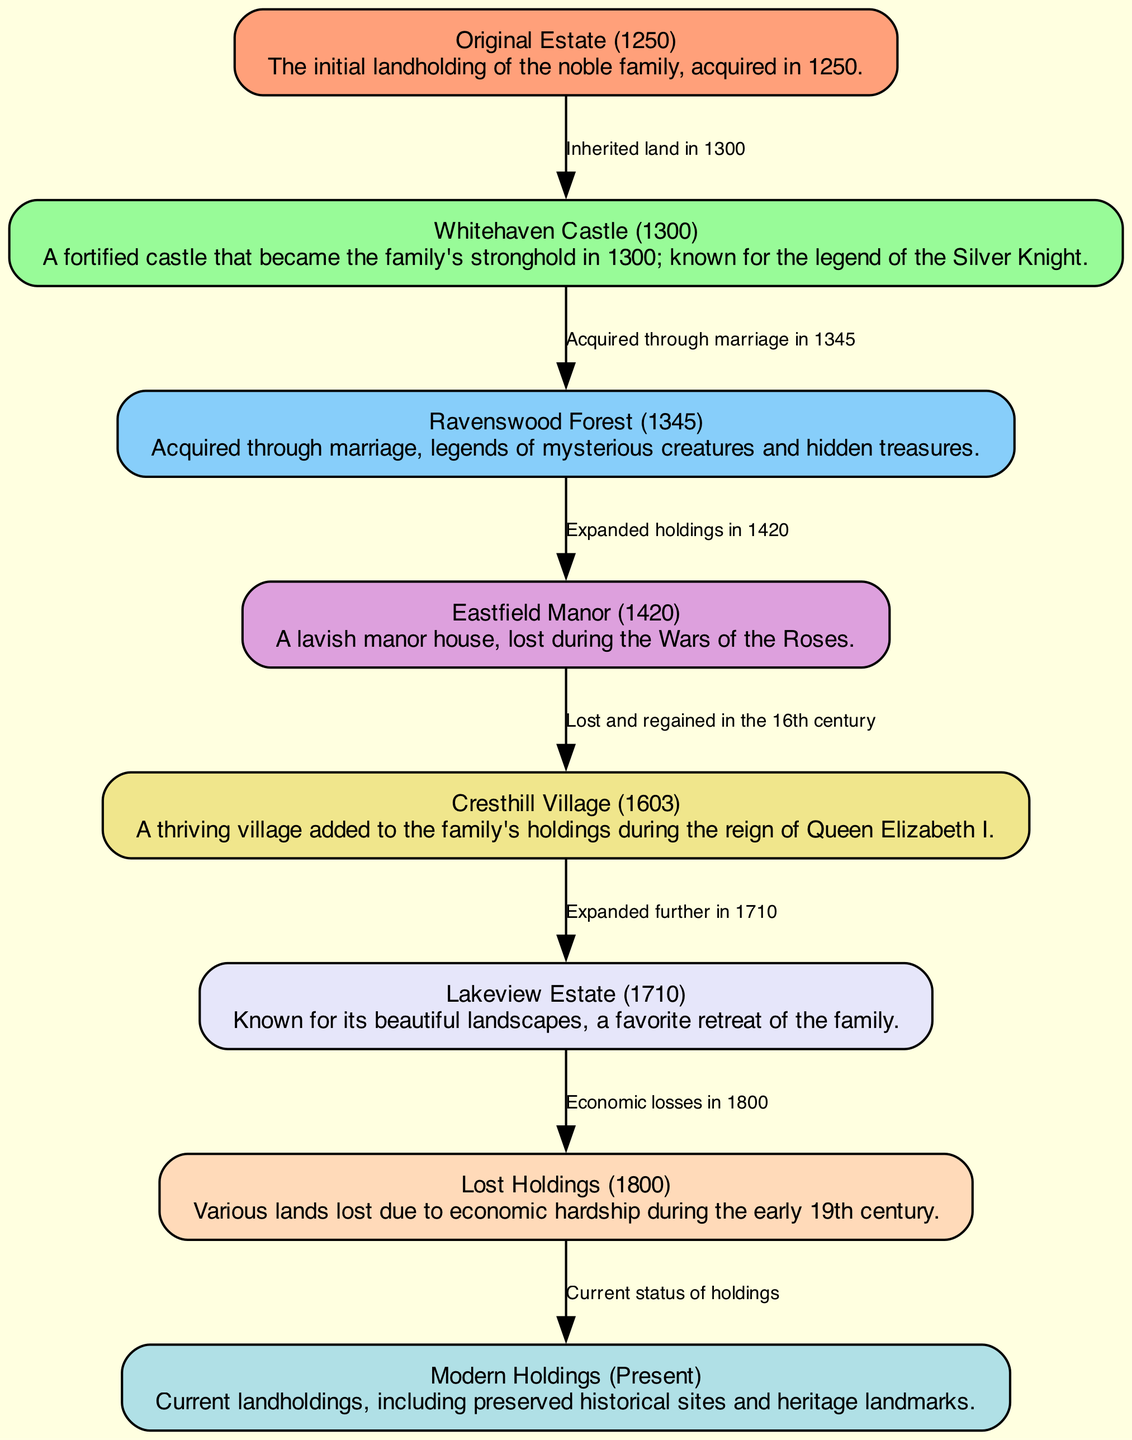What year was the Original Estate acquired? The diagram states that the Original Estate was acquired in the year 1250, as indicated in the node description.
Answer: 1250 How many significant landholdings are mentioned in the diagram? The diagram lists 8 significant landholdings, each represented as a node in the visualization.
Answer: 8 What landmark is associated with the legend of the Silver Knight? The node for Whitehaven Castle specifically mentions the legend of the Silver Knight, which is its notable story.
Answer: Whitehaven Castle Which holdings were lost during the Wars of the Roses? The node for Eastfield Manor describes it as being lost during the Wars of the Roses, indicating the specific event related to the family’s holdings.
Answer: Eastfield Manor What is the current status of landholdings according to the diagram? The last node identifies the current holdings as "Modern Holdings," which reflects the present status of the noble family's land.
Answer: Modern Holdings What connection exists between Ravenswood Forest and Eastfield Manor? The edge connecting Ravenswood Forest to Eastfield Manor indicates that the family expanded their holdings to include Eastfield Manor after acquiring Ravenswood Forest through marriage.
Answer: Expanded holdings in 1420 What significant event occurred in 1800 regarding the landholdings? The diagram shows that various lands were lost due to economic hardship in the year 1800, which is a major event impacting the family's holdings during that time.
Answer: Economic losses When was Lakeview Estate acquired? The diagram specifies that Lakeview Estate was added to the family's holdings in 1710, which is directly stated in its node description.
Answer: 1710 What is a notable feature of Cresthill Village? The node for Cresthill Village notes that it was a thriving village added during the reign of Queen Elizabeth I, signifying its importance to the landholdings.
Answer: A thriving village 